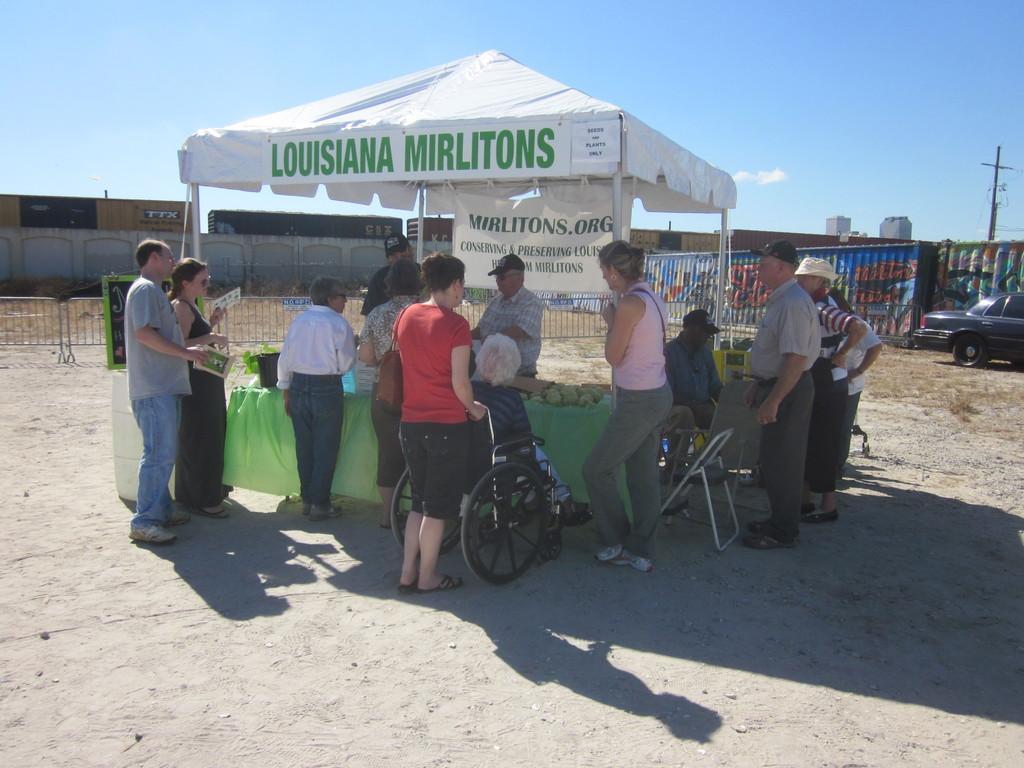Please provide a concise description of this image. In this picture there are group of people standing and there is a man sitting on the chair and there is a person sitting on the wheel chair. There is a tent and there is text on the tent and there is a banner there is text on the banner and there are objects on the table. At the back there is a railing and there are containers and there is a pole and there is a vehicle. At the top there is sky. At the bottom there is ground. 